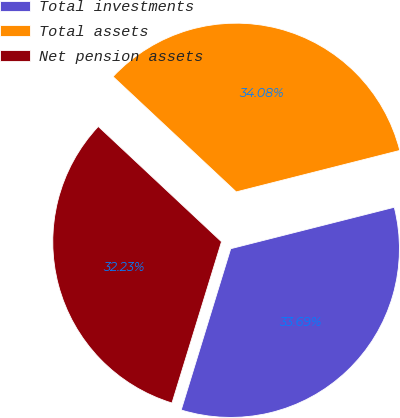<chart> <loc_0><loc_0><loc_500><loc_500><pie_chart><fcel>Total investments<fcel>Total assets<fcel>Net pension assets<nl><fcel>33.69%<fcel>34.08%<fcel>32.23%<nl></chart> 